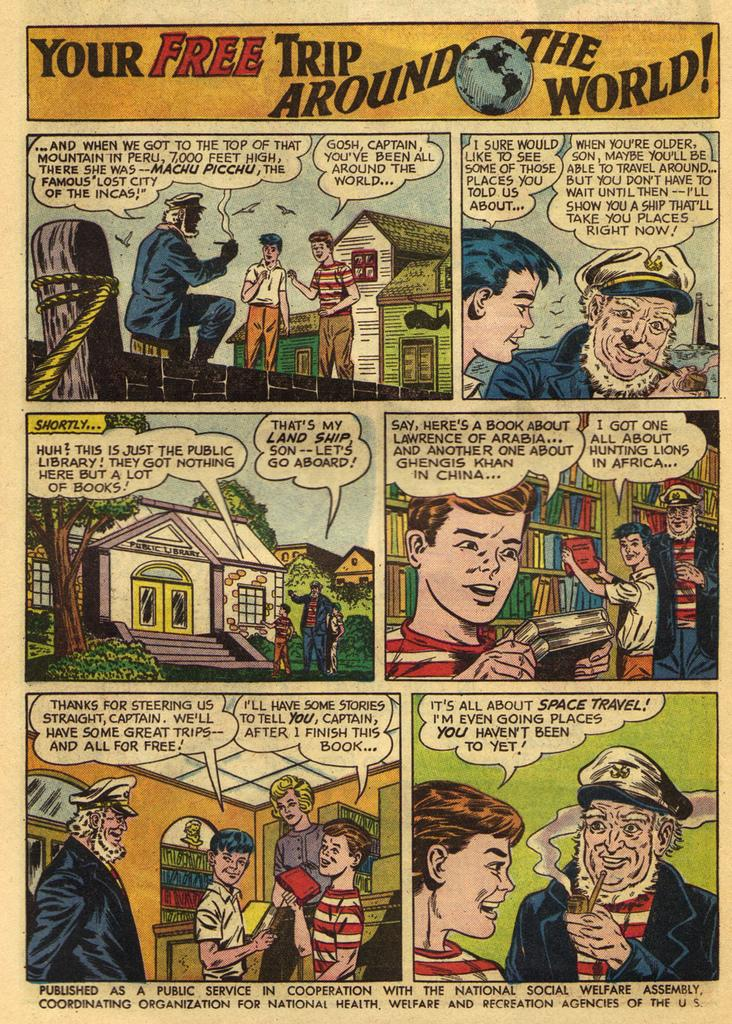<image>
Share a concise interpretation of the image provided. The comic advertises a free trip around the world. 